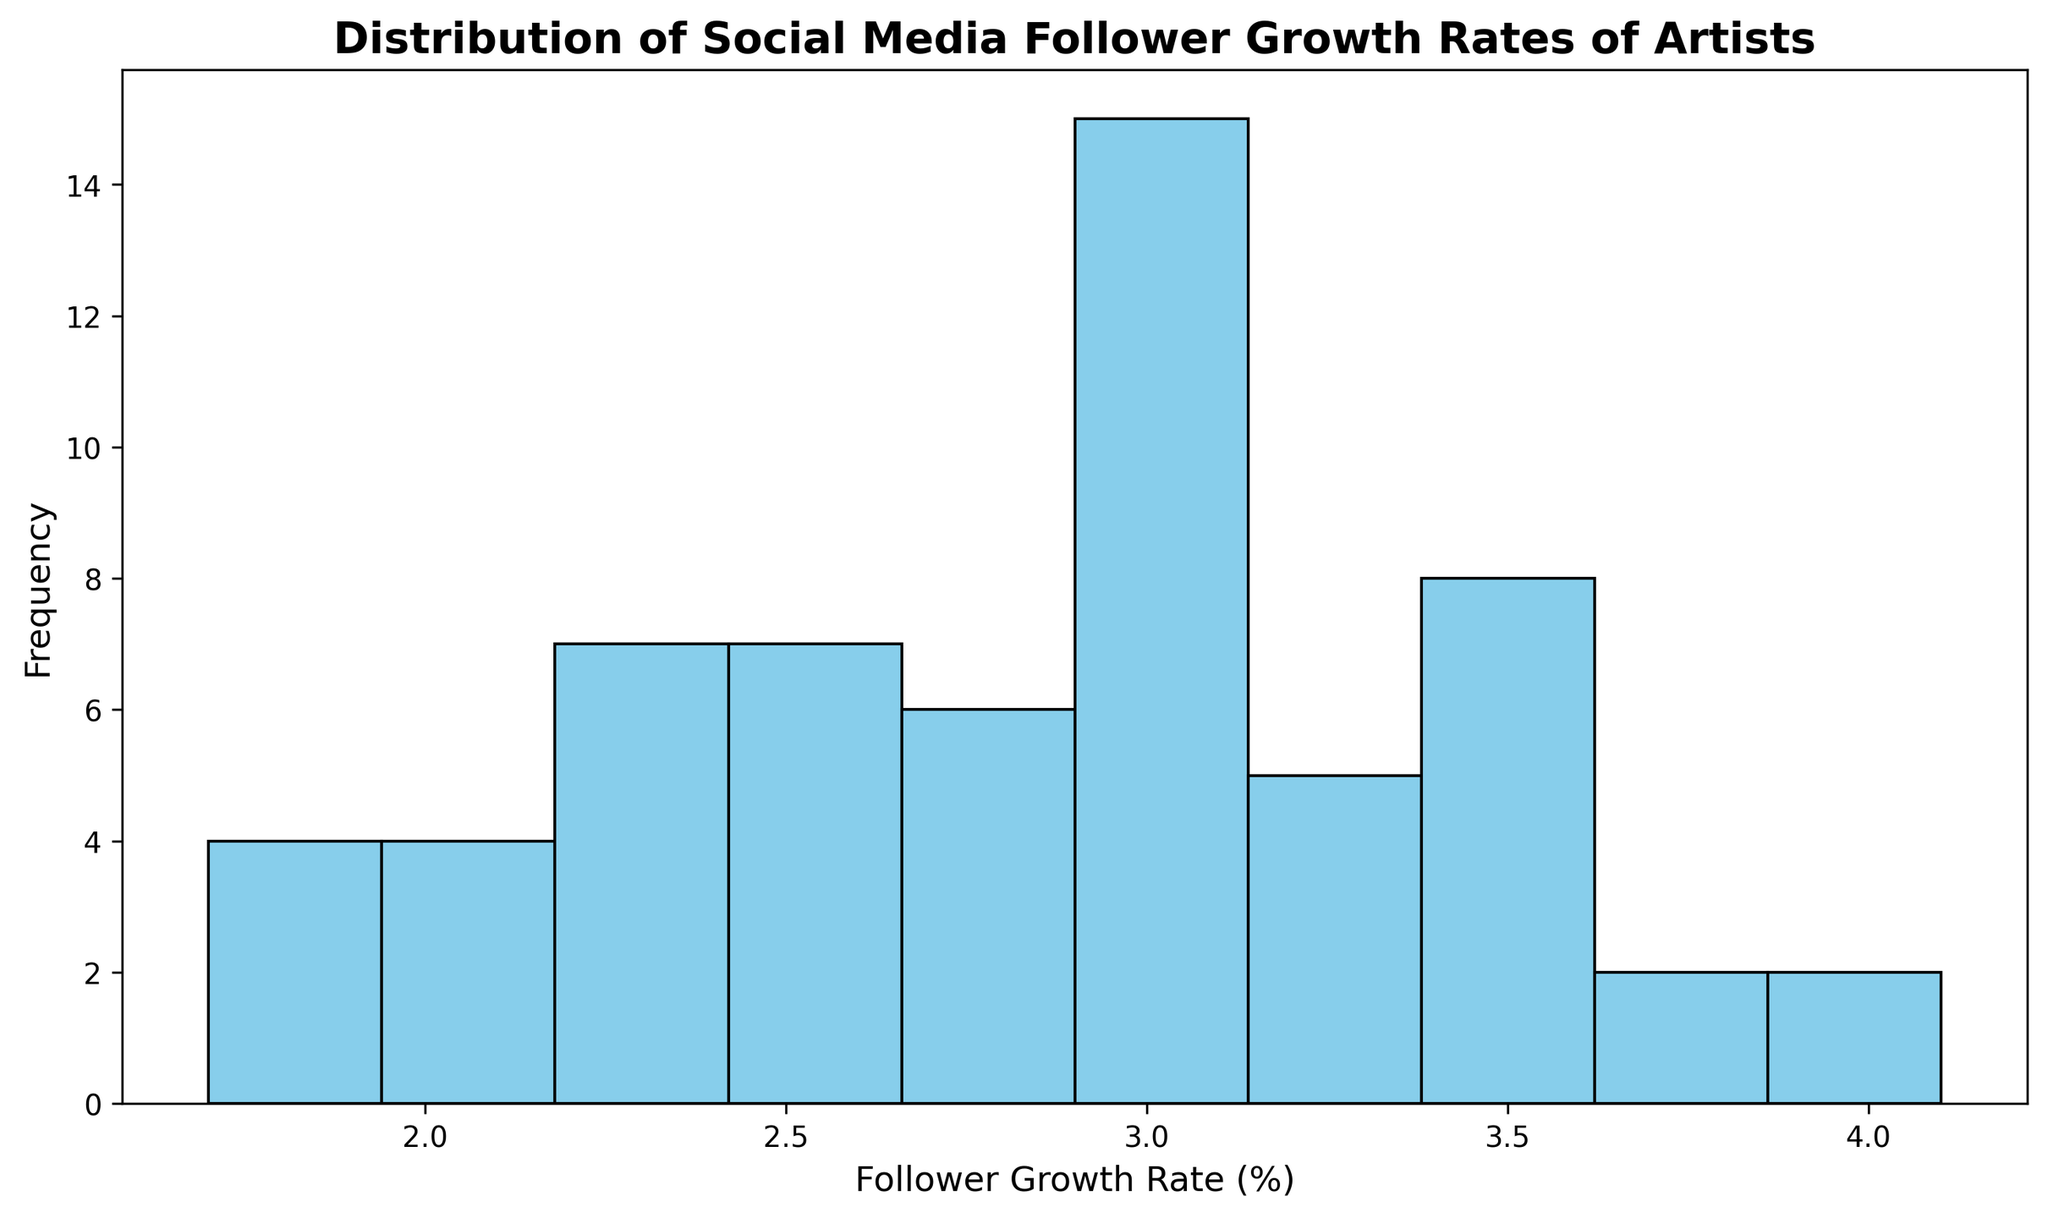What is the most frequent follower growth rate range? Look for the tallest bar in the histogram. The range corresponds to the interval on the x-axis represented by this bar.
Answer: 2.5 - 3.0% What is the total number of artists with follower growth rates between 2.5% and 3.0%? Identify the bar for the 2.5 - 3.0% range, then read off the height or frequency of that bar.
Answer: 14 Is the follower growth rate distribution skewed to higher or lower values? Assess the shape of the histogram by comparing the frequency of bars at the lower end versus the higher end of the growth rates.
Answer: Lower values How many follower growth rate ranges have frequencies higher than 8? Count all the bars (x-axis ranges) with heights (frequencies) exceeding 8.
Answer: 1 What is the sum of frequencies for growth rates above 3.5%? Locate all bars for growth rates above 3.5% and sum their frequencies. Suppose there are 3 such bars with frequencies 4, 5, and 3 respectively.
Answer: 12 Which follower growth rate range has the lowest frequency? Find the shortest bar in the histogram and identify the corresponding x-axis range.
Answer: 1.5 - 2.0% Compare the frequency of the 3.0 - 3.5% range to the 2.0 - 2.5% range. Which is higher? Look at the heights of bars for both the 3.0 - 3.5% range and 2.0 - 2.5% range. The bar with a greater height represents the range with a higher frequency.
Answer: 3.0 - 3.5% Are there more artists with a follower growth rate below 2.5% or above 3.5%? Sum the frequencies of all bars below 2.5% and all bars above 3.5%. Compare these two sums.
Answer: Below 2.5% What is the average frequency of the follower growth rate ranges? Sum all the frequencies and divide by the number of bins (ranges). Suppose there are a total of 68 data points and 10 bins. The sum of frequencies is 68, and there are 10 bins.
Answer: 6.8 